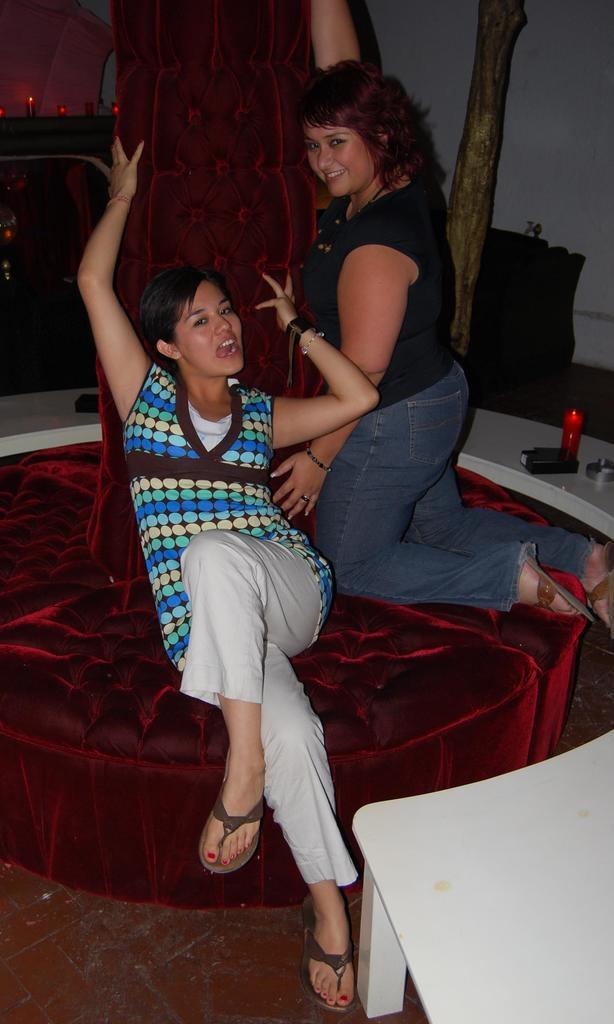In one or two sentences, can you explain what this image depicts? In this image I can see there are the two woman sit on the sofa set and their mouth is open,and back ground I can see there is a light , on the table there are some objects kept on that. 